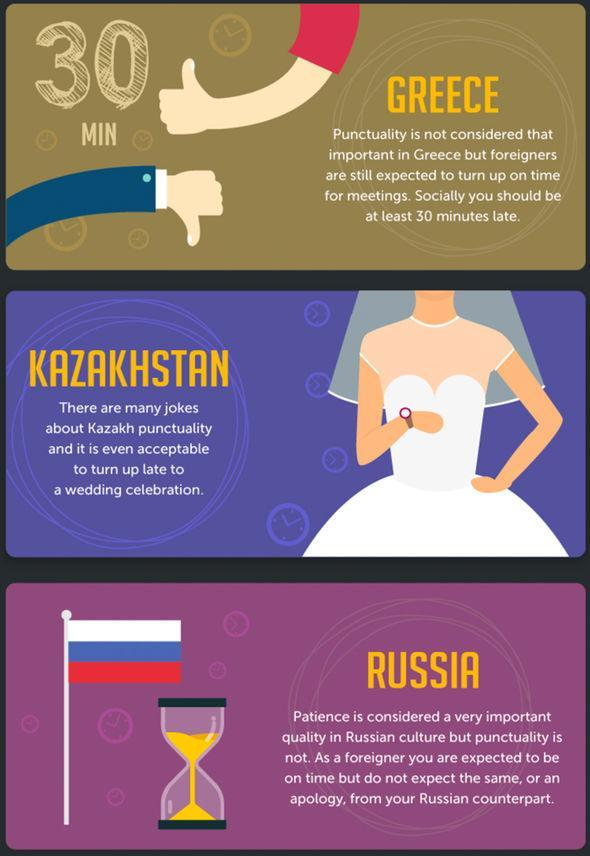Which are the three countries mentioned here ?
Answer the question with a short phrase. Russia, Greece, Kazakhstan In which country, is it good to be late by 30 minutes for social gatherings ? Greece What is the image used to show the importance of punctuality in Kazakhstan - an hourglass, a flag or a bride ? A Bride Which country's flag is shown in the image ? Russia What is considered more important than punctuality in Russia ? Patience What does the bride have on her hand - watch, bracelet or bangle ? Watch 